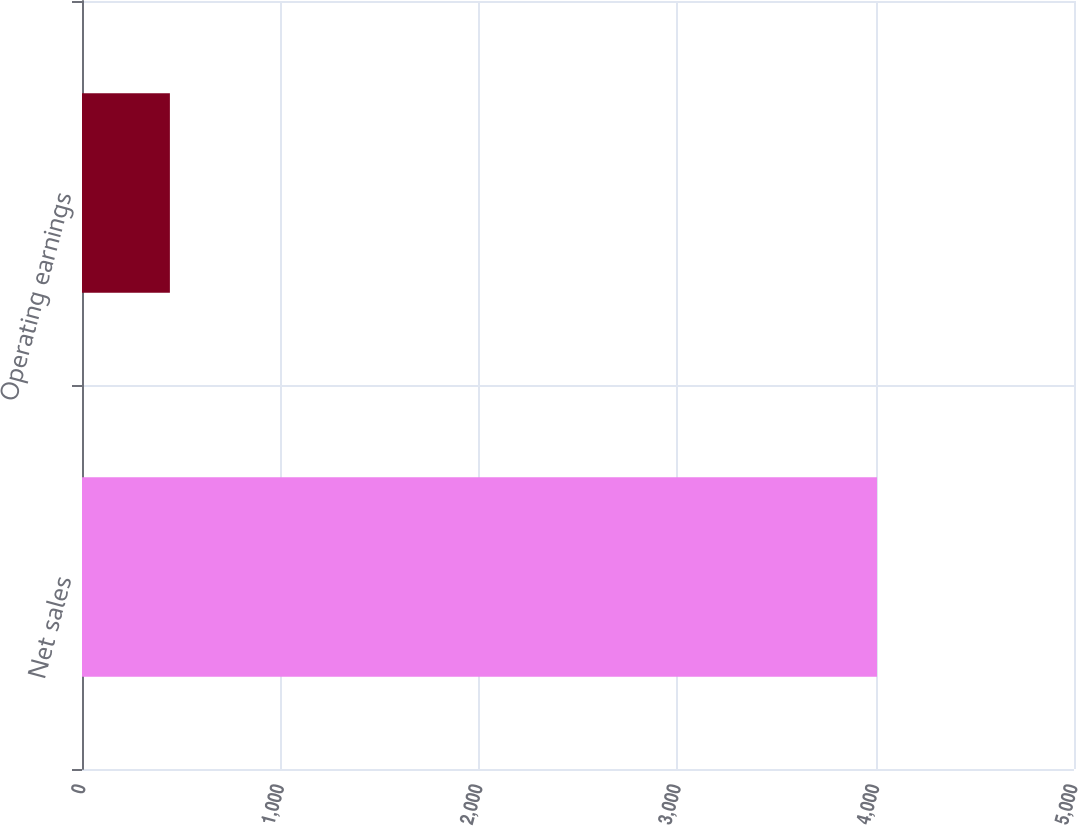Convert chart to OTSL. <chart><loc_0><loc_0><loc_500><loc_500><bar_chart><fcel>Net sales<fcel>Operating earnings<nl><fcel>4007<fcel>443<nl></chart> 